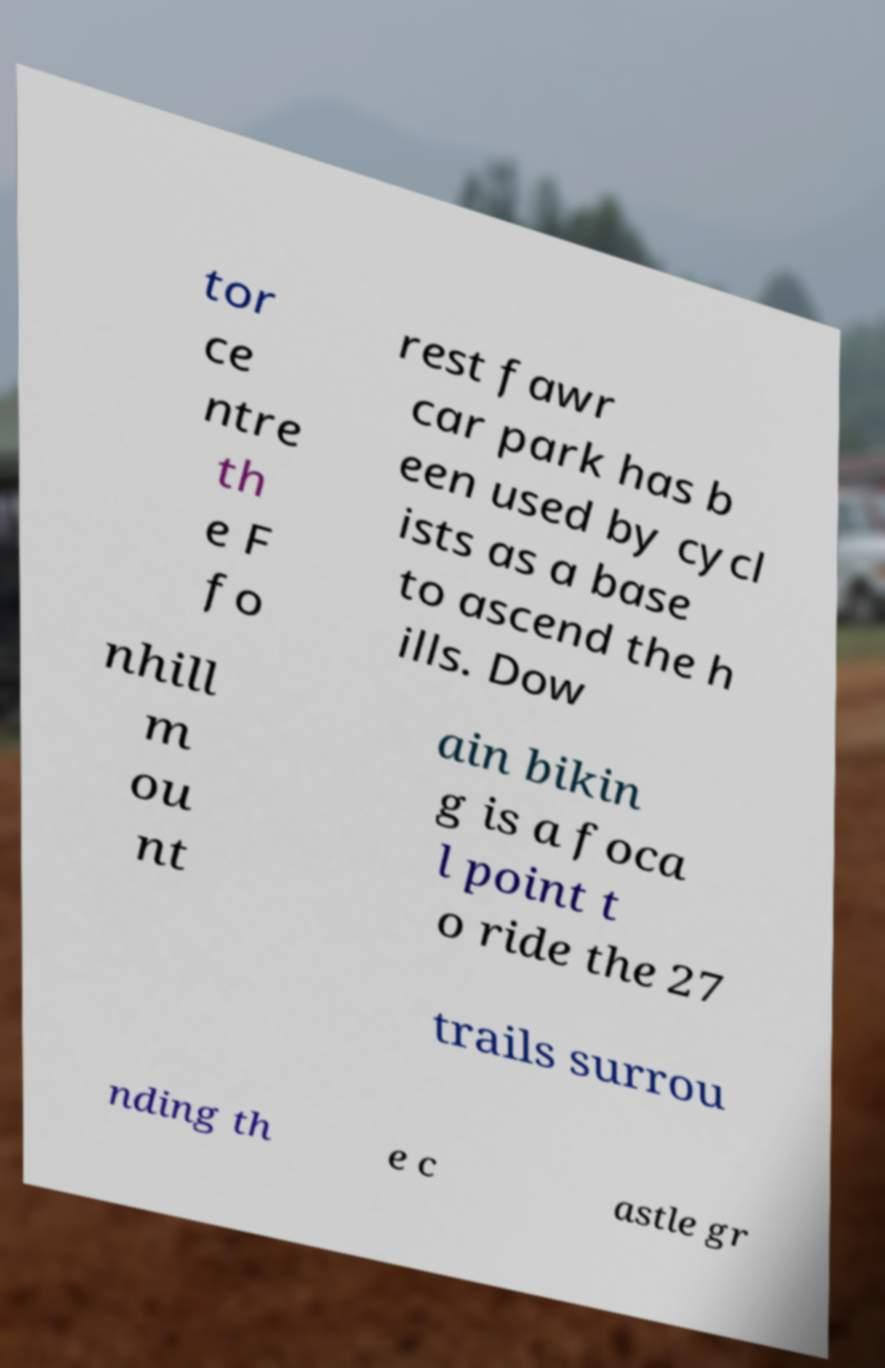Can you read and provide the text displayed in the image?This photo seems to have some interesting text. Can you extract and type it out for me? tor ce ntre th e F fo rest fawr car park has b een used by cycl ists as a base to ascend the h ills. Dow nhill m ou nt ain bikin g is a foca l point t o ride the 27 trails surrou nding th e c astle gr 